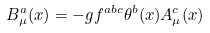<formula> <loc_0><loc_0><loc_500><loc_500>B _ { \mu } ^ { a } ( x ) = - g f ^ { a b c } \theta ^ { b } ( x ) A _ { \mu } ^ { c } ( x )</formula> 